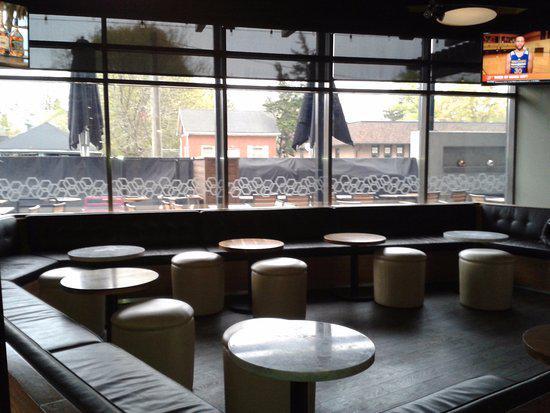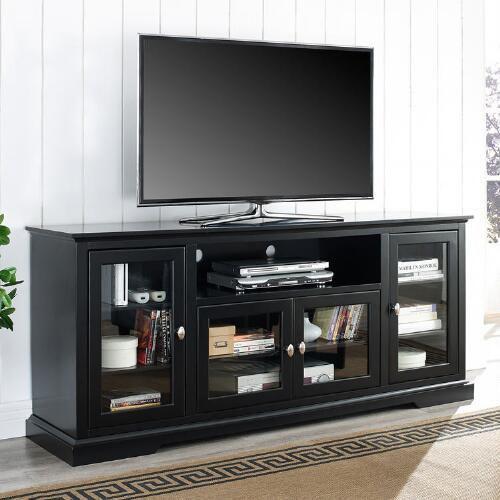The first image is the image on the left, the second image is the image on the right. Assess this claim about the two images: "There is only one tv in each image". Correct or not? Answer yes or no. No. The first image is the image on the left, the second image is the image on the right. Evaluate the accuracy of this statement regarding the images: "Someone is watching TV white sitting on a couch in the right image.". Is it true? Answer yes or no. No. 